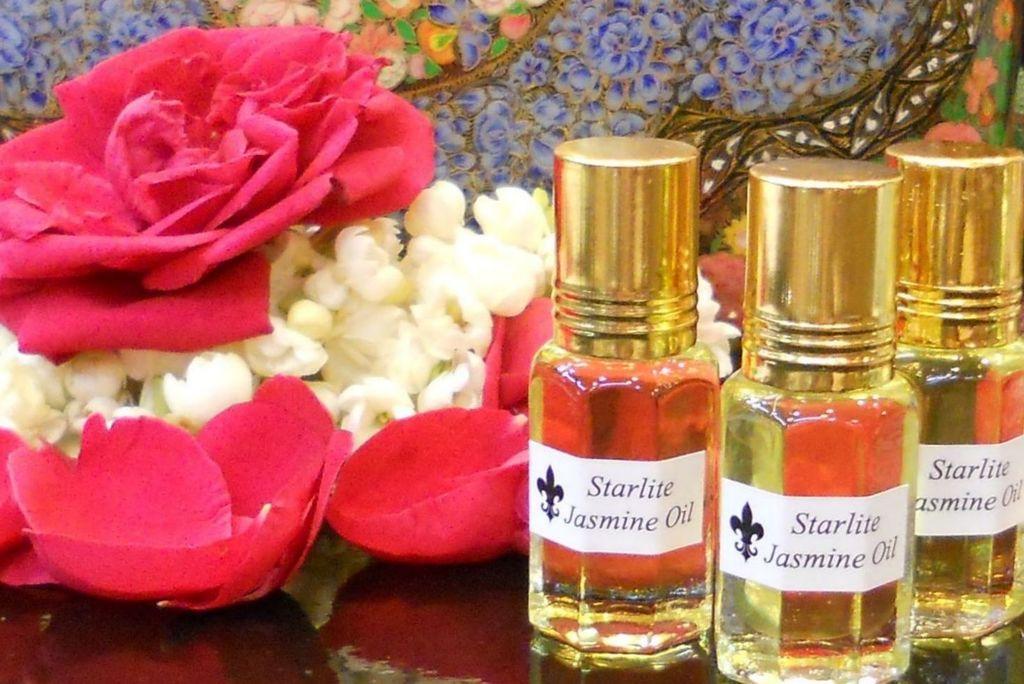What type of oil is in the bottles?
Provide a succinct answer. Starlite jasmine oil. Is oil or water in the bottle?
Your response must be concise. Oil. 